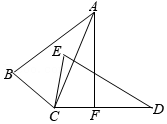In the given diagram, triangle ABC is congruent to triangle DEC, with corresponding vertices A and D, and B and E. A perpendicular line AF is drawn through point A, intersecting CD at point F. If angle BCE is represented by the variable 'x' (x = 60°), what is the measure of angle CAF? Express the angle as 'y' in terms of 'x'. To determine the measure of angle CAF, let's leverage the given congruences between triangles ABC and DEC. This congruence implies that each corresponding angle in one triangle is equivalent to its counterpart in the other. Thus, angle DCE equals angle ACB. When considering the line AF, which perpendicularly intersects line segment CD at F, it introduces two right angles at F, specifically angles AFD and AFC, each measuring 90°. Because angle BCE (which is x and given as 60°) is congruent to angle ACD due to the triangles' congruency, angle ACD must also be 60°. Since angle AFC is a right angle (90°), subtracting angle ACD from it gives us angle CAF as 90° - 60° = 30°. Thus, angle CAF measures 30°, represented here as y = 30° in terms of x. 